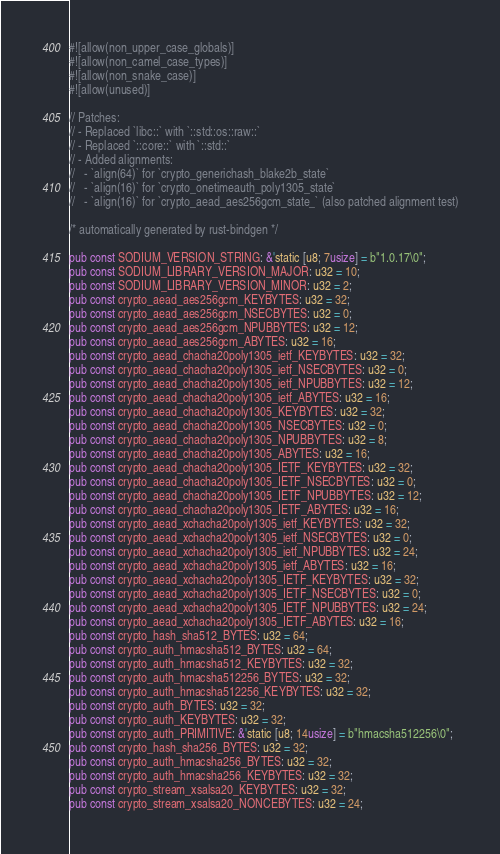Convert code to text. <code><loc_0><loc_0><loc_500><loc_500><_Rust_>#![allow(non_upper_case_globals)]
#![allow(non_camel_case_types)]
#![allow(non_snake_case)]
#![allow(unused)]

// Patches:
// - Replaced `libc::` with `::std::os::raw::`
// - Replaced `::core::` with `::std::`
// - Added alignments:
//   - `align(64)` for `crypto_generichash_blake2b_state`
//   - `align(16)` for `crypto_onetimeauth_poly1305_state`
//   - `align(16)` for `crypto_aead_aes256gcm_state_` (also patched alignment test)

/* automatically generated by rust-bindgen */

pub const SODIUM_VERSION_STRING: &'static [u8; 7usize] = b"1.0.17\0";
pub const SODIUM_LIBRARY_VERSION_MAJOR: u32 = 10;
pub const SODIUM_LIBRARY_VERSION_MINOR: u32 = 2;
pub const crypto_aead_aes256gcm_KEYBYTES: u32 = 32;
pub const crypto_aead_aes256gcm_NSECBYTES: u32 = 0;
pub const crypto_aead_aes256gcm_NPUBBYTES: u32 = 12;
pub const crypto_aead_aes256gcm_ABYTES: u32 = 16;
pub const crypto_aead_chacha20poly1305_ietf_KEYBYTES: u32 = 32;
pub const crypto_aead_chacha20poly1305_ietf_NSECBYTES: u32 = 0;
pub const crypto_aead_chacha20poly1305_ietf_NPUBBYTES: u32 = 12;
pub const crypto_aead_chacha20poly1305_ietf_ABYTES: u32 = 16;
pub const crypto_aead_chacha20poly1305_KEYBYTES: u32 = 32;
pub const crypto_aead_chacha20poly1305_NSECBYTES: u32 = 0;
pub const crypto_aead_chacha20poly1305_NPUBBYTES: u32 = 8;
pub const crypto_aead_chacha20poly1305_ABYTES: u32 = 16;
pub const crypto_aead_chacha20poly1305_IETF_KEYBYTES: u32 = 32;
pub const crypto_aead_chacha20poly1305_IETF_NSECBYTES: u32 = 0;
pub const crypto_aead_chacha20poly1305_IETF_NPUBBYTES: u32 = 12;
pub const crypto_aead_chacha20poly1305_IETF_ABYTES: u32 = 16;
pub const crypto_aead_xchacha20poly1305_ietf_KEYBYTES: u32 = 32;
pub const crypto_aead_xchacha20poly1305_ietf_NSECBYTES: u32 = 0;
pub const crypto_aead_xchacha20poly1305_ietf_NPUBBYTES: u32 = 24;
pub const crypto_aead_xchacha20poly1305_ietf_ABYTES: u32 = 16;
pub const crypto_aead_xchacha20poly1305_IETF_KEYBYTES: u32 = 32;
pub const crypto_aead_xchacha20poly1305_IETF_NSECBYTES: u32 = 0;
pub const crypto_aead_xchacha20poly1305_IETF_NPUBBYTES: u32 = 24;
pub const crypto_aead_xchacha20poly1305_IETF_ABYTES: u32 = 16;
pub const crypto_hash_sha512_BYTES: u32 = 64;
pub const crypto_auth_hmacsha512_BYTES: u32 = 64;
pub const crypto_auth_hmacsha512_KEYBYTES: u32 = 32;
pub const crypto_auth_hmacsha512256_BYTES: u32 = 32;
pub const crypto_auth_hmacsha512256_KEYBYTES: u32 = 32;
pub const crypto_auth_BYTES: u32 = 32;
pub const crypto_auth_KEYBYTES: u32 = 32;
pub const crypto_auth_PRIMITIVE: &'static [u8; 14usize] = b"hmacsha512256\0";
pub const crypto_hash_sha256_BYTES: u32 = 32;
pub const crypto_auth_hmacsha256_BYTES: u32 = 32;
pub const crypto_auth_hmacsha256_KEYBYTES: u32 = 32;
pub const crypto_stream_xsalsa20_KEYBYTES: u32 = 32;
pub const crypto_stream_xsalsa20_NONCEBYTES: u32 = 24;</code> 